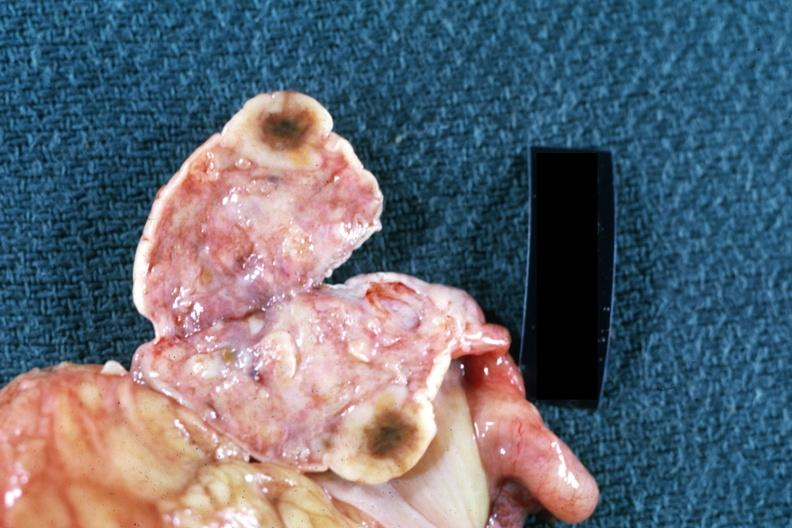what does this image show?
Answer the question using a single word or phrase. Close-up single lesion well shown breast primary 